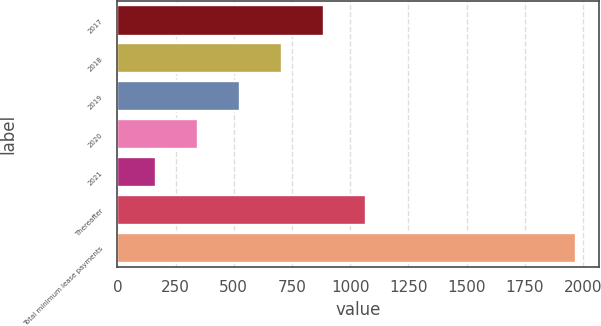Convert chart. <chart><loc_0><loc_0><loc_500><loc_500><bar_chart><fcel>2017<fcel>2018<fcel>2019<fcel>2020<fcel>2021<fcel>Thereafter<fcel>Total minimum lease payments<nl><fcel>888.8<fcel>708.6<fcel>528.4<fcel>348.2<fcel>168<fcel>1069<fcel>1970<nl></chart> 